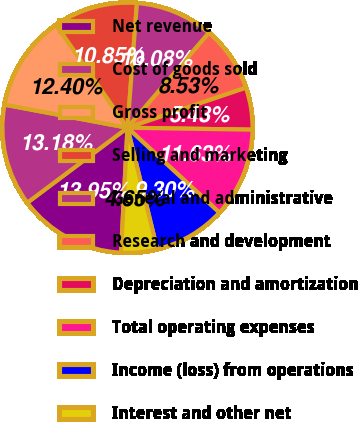<chart> <loc_0><loc_0><loc_500><loc_500><pie_chart><fcel>Net revenue<fcel>Cost of goods sold<fcel>Gross profit<fcel>Selling and marketing<fcel>General and administrative<fcel>Research and development<fcel>Depreciation and amortization<fcel>Total operating expenses<fcel>Income (loss) from operations<fcel>Interest and other net<nl><fcel>13.95%<fcel>13.18%<fcel>12.4%<fcel>10.85%<fcel>10.08%<fcel>8.53%<fcel>5.43%<fcel>11.63%<fcel>9.3%<fcel>4.65%<nl></chart> 